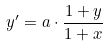Convert formula to latex. <formula><loc_0><loc_0><loc_500><loc_500>y ^ { \prime } = a \cdot \frac { 1 + y } { 1 + x }</formula> 